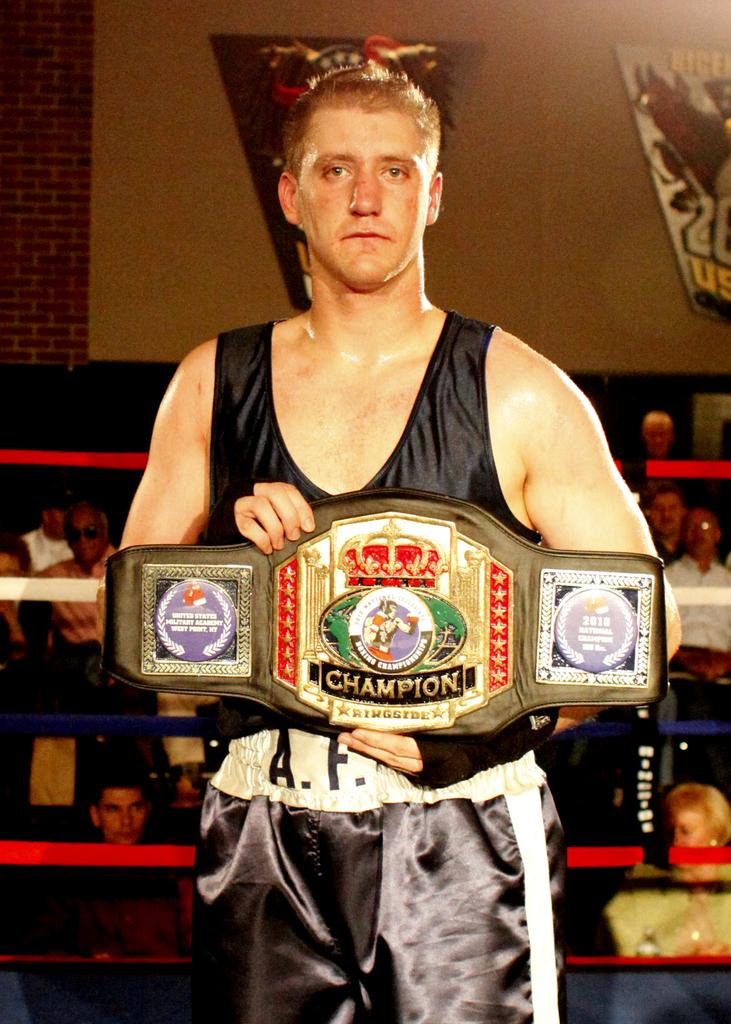<image>
Share a concise interpretation of the image provided. a man holding a champion belt up in a uniform 